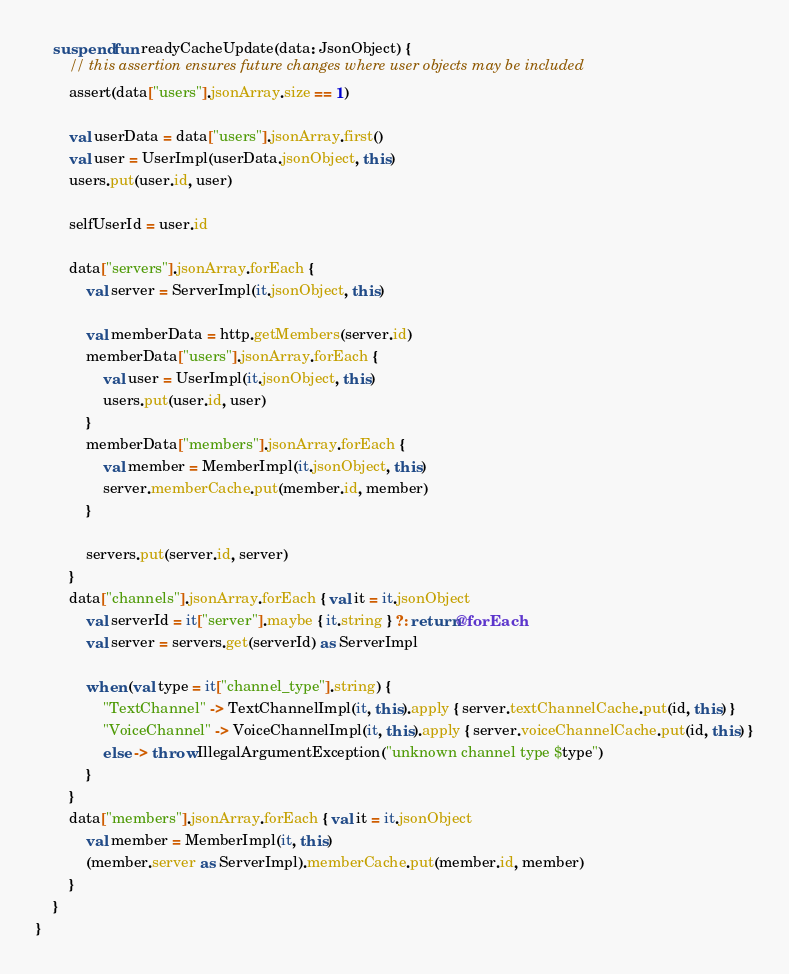Convert code to text. <code><loc_0><loc_0><loc_500><loc_500><_Kotlin_>
    suspend fun readyCacheUpdate(data: JsonObject) {
        // this assertion ensures future changes where user objects may be included
        assert(data["users"].jsonArray.size == 1)

        val userData = data["users"].jsonArray.first()
        val user = UserImpl(userData.jsonObject, this)
        users.put(user.id, user)

        selfUserId = user.id

        data["servers"].jsonArray.forEach {
            val server = ServerImpl(it.jsonObject, this)

            val memberData = http.getMembers(server.id)
            memberData["users"].jsonArray.forEach {
                val user = UserImpl(it.jsonObject, this)
                users.put(user.id, user)
            }
            memberData["members"].jsonArray.forEach {
                val member = MemberImpl(it.jsonObject, this)
                server.memberCache.put(member.id, member)
            }

            servers.put(server.id, server)
        }
        data["channels"].jsonArray.forEach { val it = it.jsonObject
            val serverId = it["server"].maybe { it.string } ?: return@forEach
            val server = servers.get(serverId) as ServerImpl

            when (val type = it["channel_type"].string) {
                "TextChannel" -> TextChannelImpl(it, this).apply { server.textChannelCache.put(id, this) }
                "VoiceChannel" -> VoiceChannelImpl(it, this).apply { server.voiceChannelCache.put(id, this) }
                else -> throw IllegalArgumentException("unknown channel type $type")
            }
        }
        data["members"].jsonArray.forEach { val it = it.jsonObject
            val member = MemberImpl(it, this)
            (member.server as ServerImpl).memberCache.put(member.id, member)
        }
    }
}</code> 